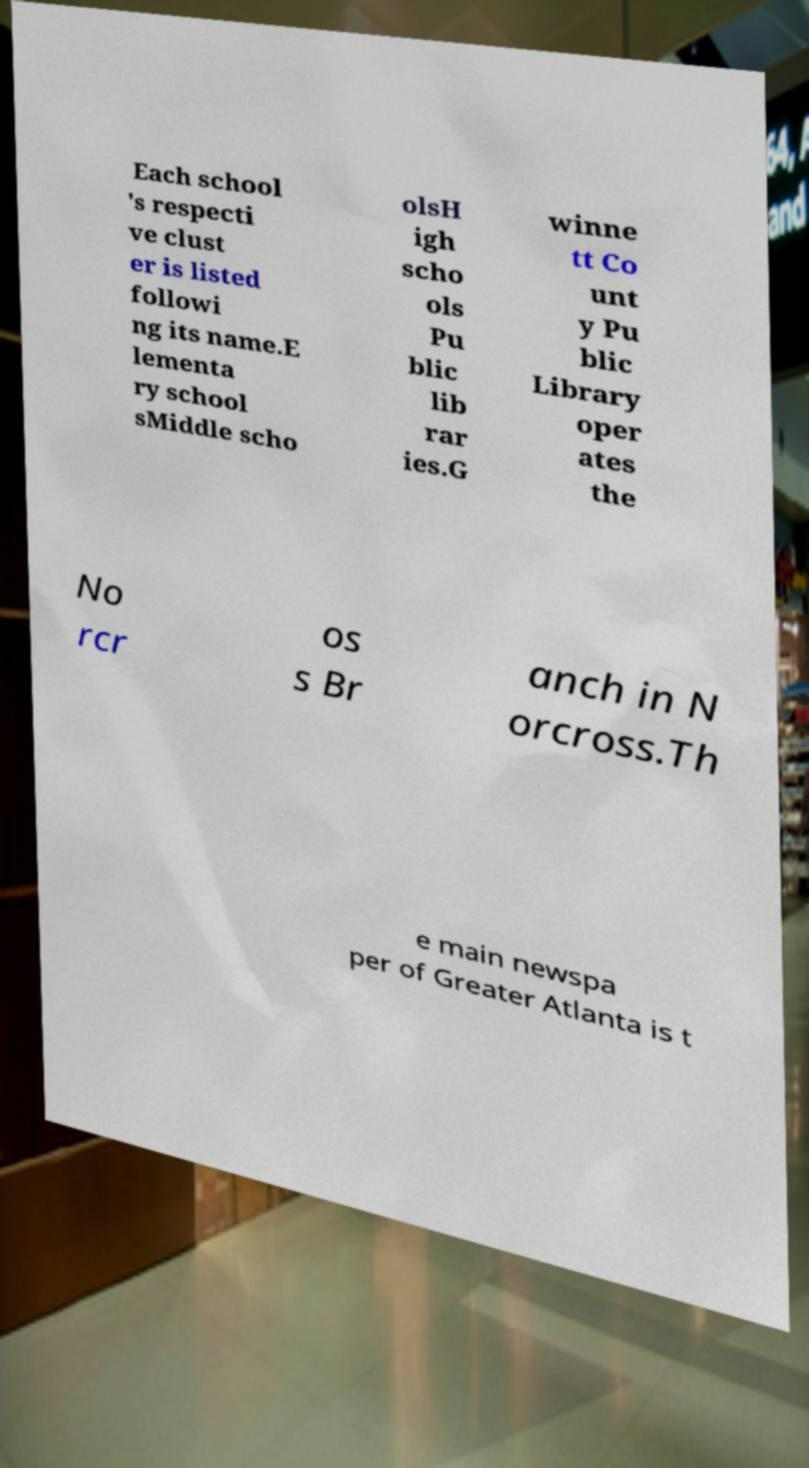Could you extract and type out the text from this image? Each school 's respecti ve clust er is listed followi ng its name.E lementa ry school sMiddle scho olsH igh scho ols Pu blic lib rar ies.G winne tt Co unt y Pu blic Library oper ates the No rcr os s Br anch in N orcross.Th e main newspa per of Greater Atlanta is t 